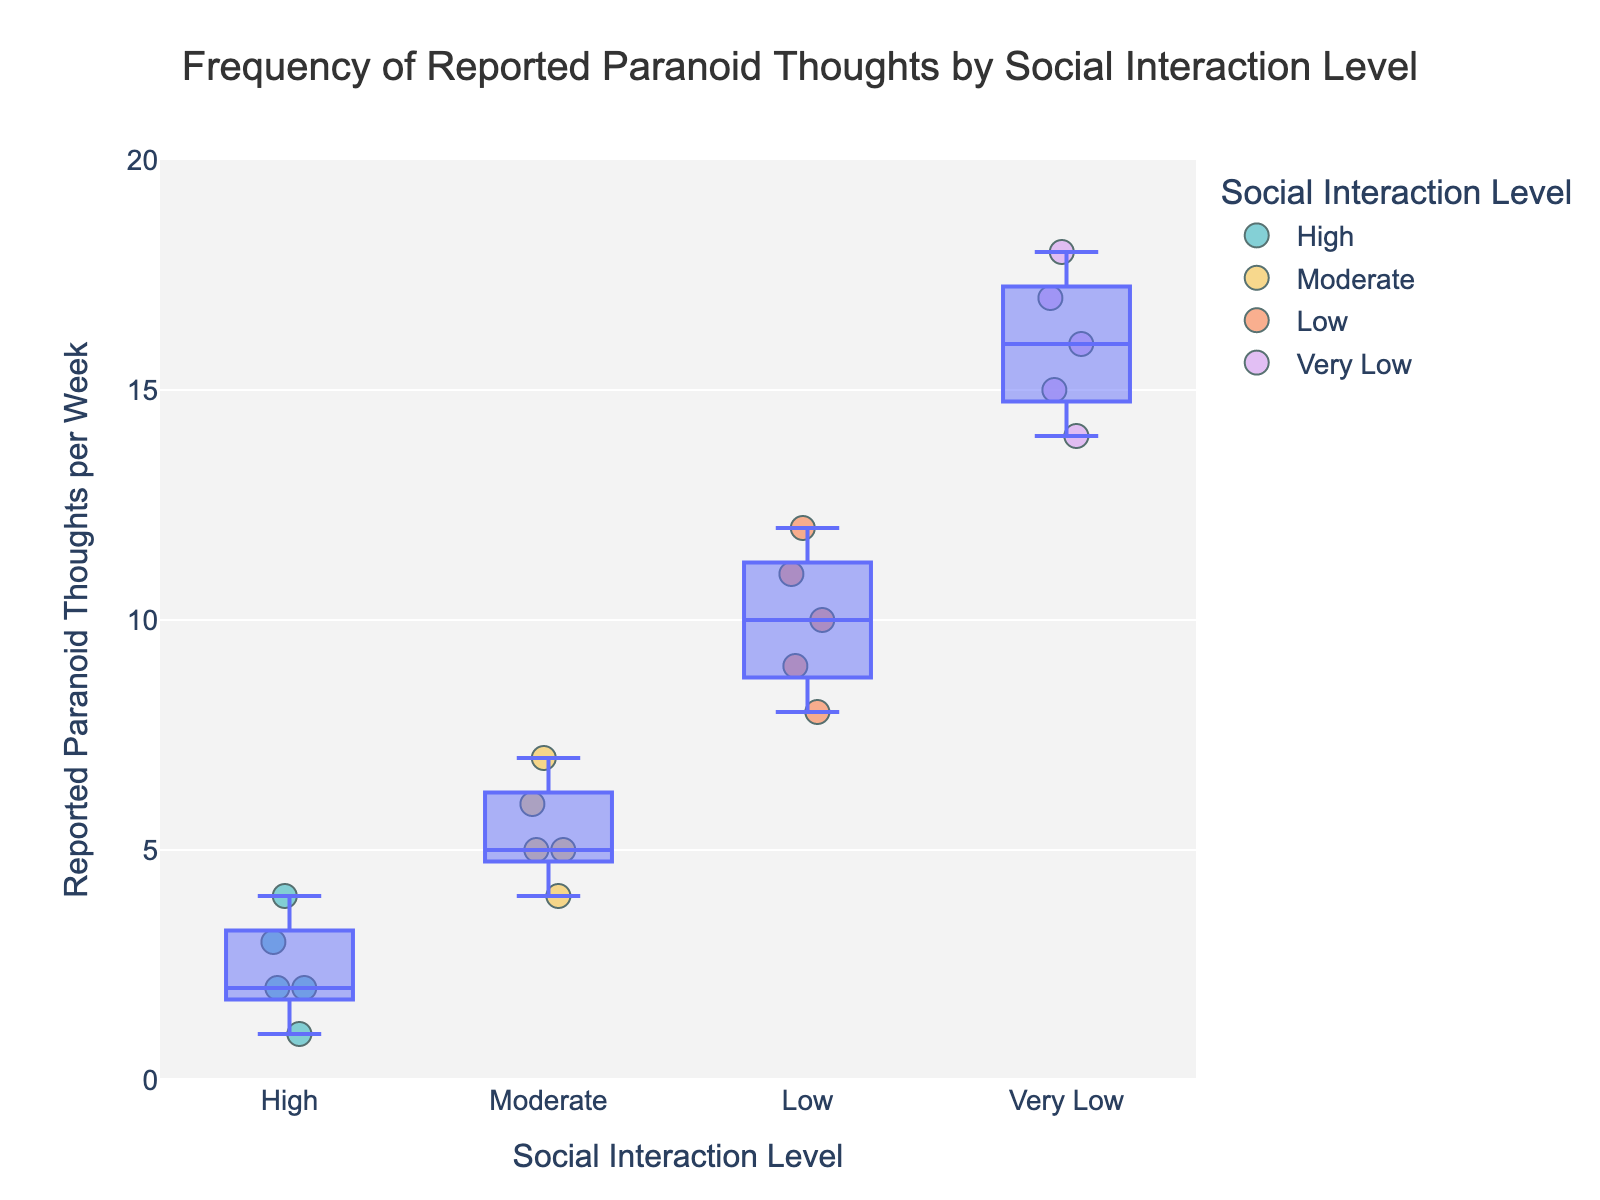What is the title of the figure? The title is generally found at the top of the figure and summarizes what the plot represents. In this case, it is provided within the script as "Frequency of Reported Paranoid Thoughts by Social Interaction Level".
Answer: Frequency of Reported Paranoid Thoughts by Social Interaction Level What are the labels on the x-axis and y-axis? The axis labels describe what each axis represents. For this figure, the x-axis represents "Social Interaction Level" and the y-axis represents "Reported Paranoid Thoughts per Week", as indicated in the labels parameter of the script.
Answer: Social Interaction Level; Reported Paranoid Thoughts per Week How many social interaction levels are shown in the figure? The groups are differentiated by the variable "Social_Interaction_Level". There are four distinct levels given in the dataset: "High", "Moderate", "Low", and "Very Low".
Answer: Four Which social interaction level group has the highest frequency of reported paranoid thoughts? You need to compare the data points across different social interaction levels. The "Very Low" social interaction group displays the highest frequency, with values ranging between 14 and 18 reported paranoid thoughts per week.
Answer: Very Low What is the range of reported paranoid thoughts for individuals with low social interaction level? To find the range, identify the smallest and largest values in the "Low" category. The smallest value is 8 and the largest is 12, giving a range of 4 (12 - 8).
Answer: 8 to 12 How does the median value of reported paranoid thoughts compare between the "Moderate" and "High" social interaction levels? The median is the middle value when data points are ordered. For "Moderate", the values are [4, 5, 5, 6, 7] which makes 5 the median. For "High", the median of [1, 2, 2, 3, 4] is 2. The median for "Moderate" (5) is greater than for "High" (2).
Answer: Moderate has a higher median than High What is the average number of reported paranoid thoughts for the "Very Low" social interaction level group? To find the average, sum the values (15 + 18 + 14 + 17 + 16) = 80, then divide by the number of data points (5). The average is 80 / 5, which equals 16.
Answer: 16 Which social interaction level has the smallest variance in reported paranoid thoughts? Variance measures how much the values differ from the mean. For "High" the values are very close to each other (1, 2, 2, 3, 4), while "Low" and "Very Low" have wider spread. Therefore, "High" has the smallest variance.
Answer: High Is there an increasing trend of reported paranoid thoughts as social interaction level decreases? Analyze the central tendency across the social interaction levels from "High" to "Very Low". The number of reported paranoid thoughts increases from "High" (1-4) to "Very Low" (14-18), indicating an increasing trend.
Answer: Yes 